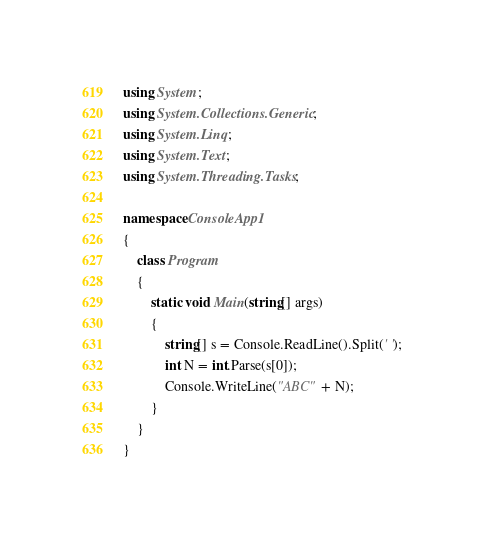Convert code to text. <code><loc_0><loc_0><loc_500><loc_500><_C#_>using System;
using System.Collections.Generic;
using System.Linq;
using System.Text;
using System.Threading.Tasks;

namespace ConsoleApp1
{
    class Program
    {
        static void Main(string[] args)
        {
            string[] s = Console.ReadLine().Split(' ');
            int N = int.Parse(s[0]);
            Console.WriteLine("ABC" + N);
        }
    }
}
</code> 